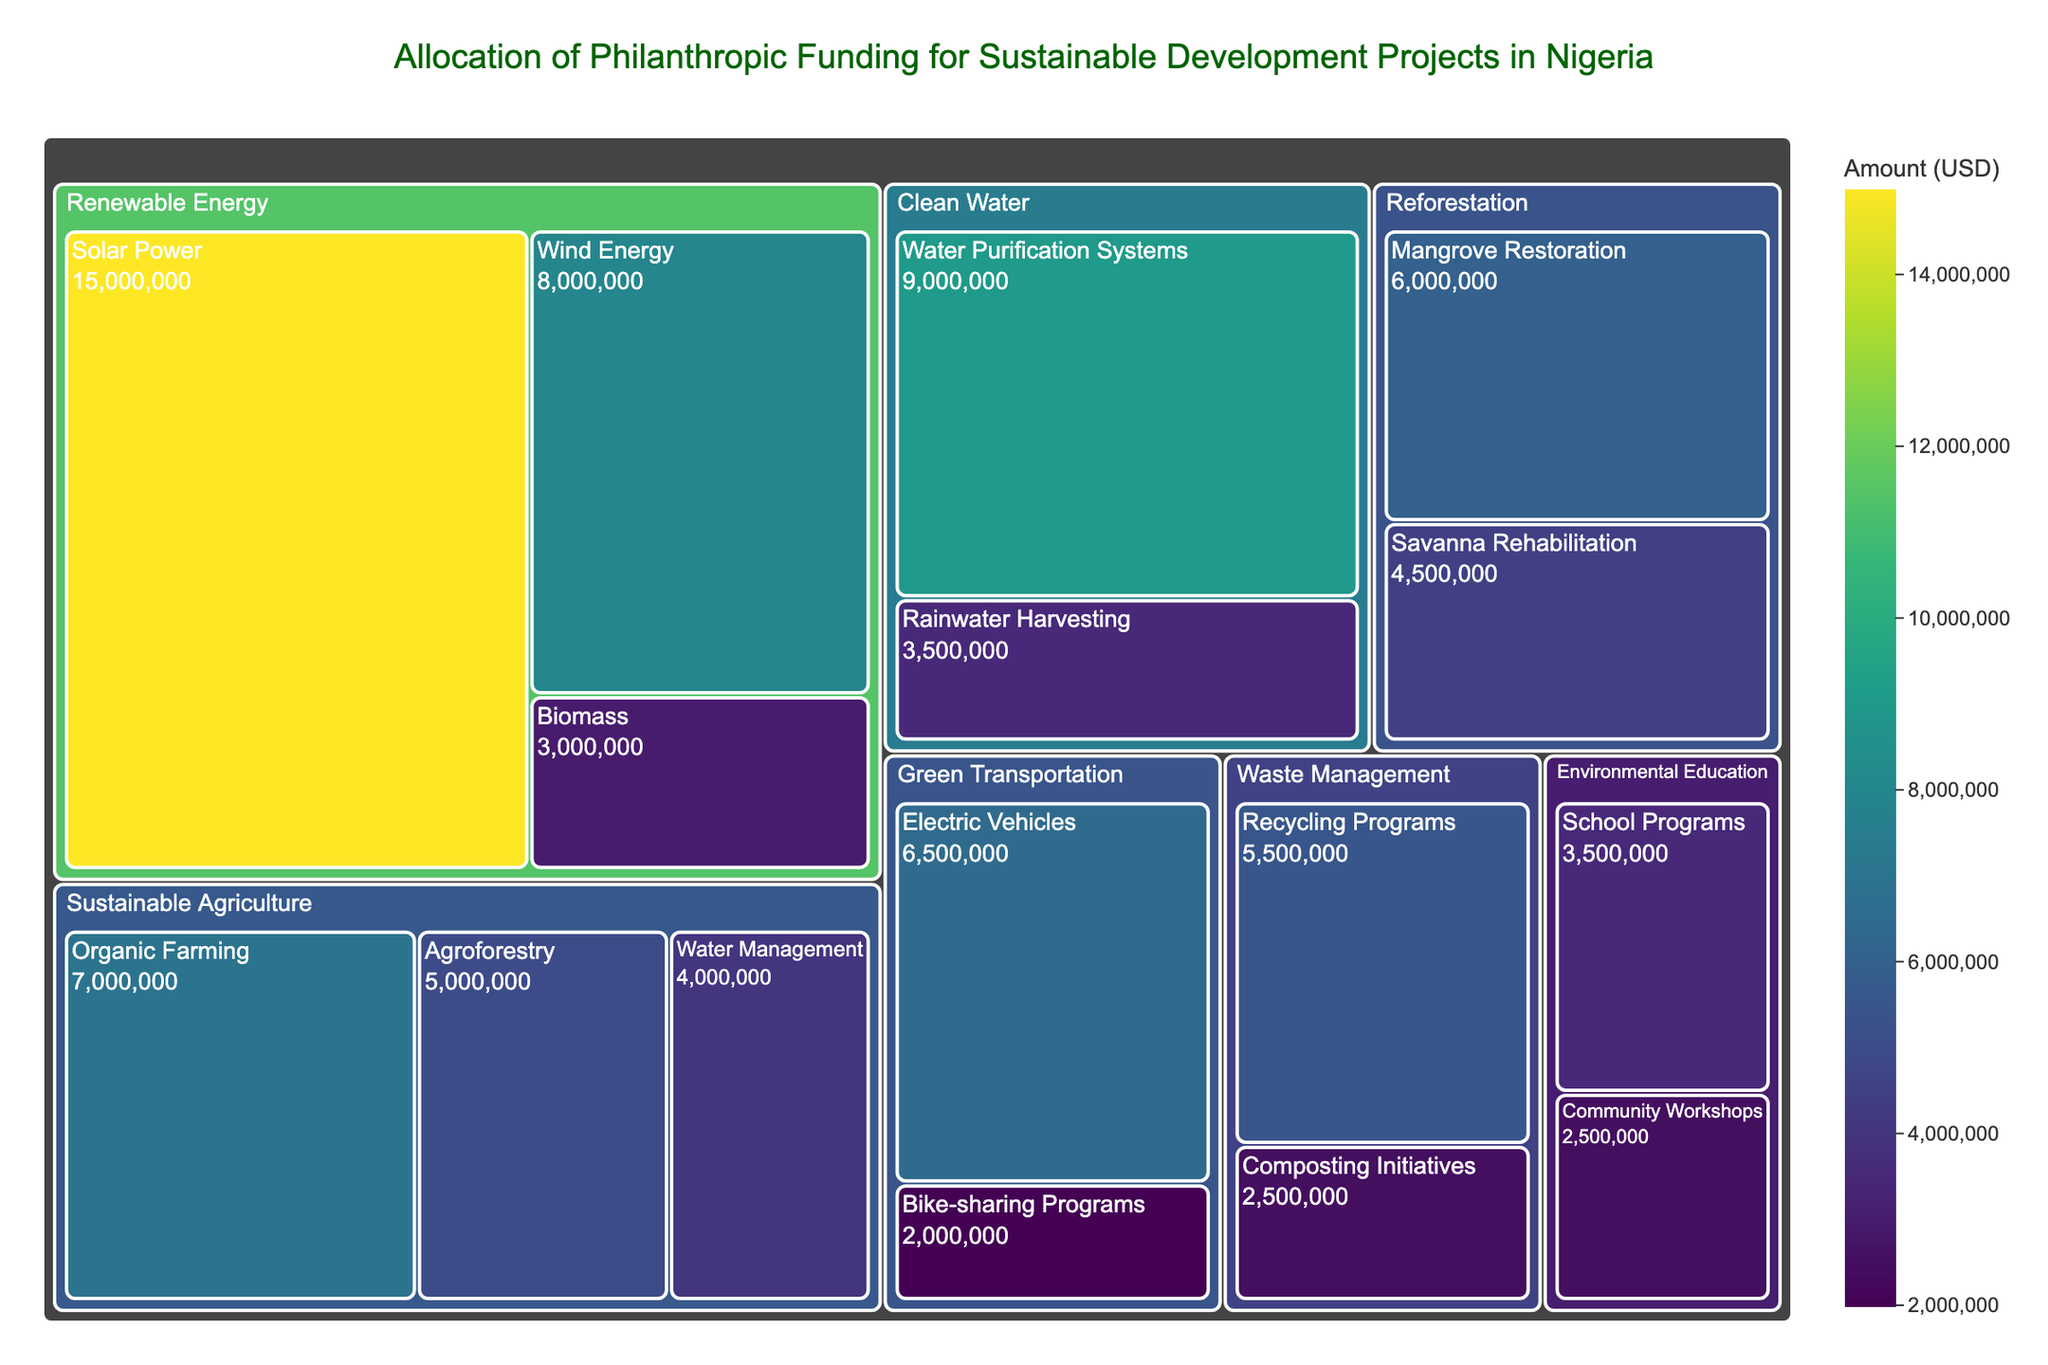What is the largest category of funding? The largest category can be identified by comparing the sizes of the blocks. The "Renewable Energy" category has the largest combined area, which indicates the highest funding amount.
Answer: Renewable Energy Which subcategory received the most funding? Within the "Renewable Energy" category, "Solar Power" is the subcategory with the largest block, indicating the highest funding.
Answer: Solar Power How much funding did Waste Management receive in total? Waste Management consists of "Recycling Programs" and "Composting Initiatives", with funding amounts of $5,500,000 and $2,500,000 respectively. Adding these gives $5,500,000 + $2,500,000 = $8,000,000.
Answer: $8,000,000 Which subcategory under Clean Water received more funding? Compare the sizes of the blocks under Clean Water. "Water Purification Systems" has a larger block than "Rainwater Harvesting."
Answer: Water Purification Systems What is the smallest category by funding amount? The smallest category can be found by identifying the smallest combined block area. "Green Transportation" has the smallest total block size.
Answer: Green Transportation What is the combined funding for Sustainable Agriculture and Reforestation? Add the total funding of Sustainable Agriculture ($7,000,000 + $5,000,000 + $4,000,000 = $16,000,000) and Reforestation ($6,000,000 + $4,500,000 = $10,500,000). The combined funding is $16,000,000 + $10,500,000 = $26,500,000.
Answer: $26,500,000 Which subcategory under Sustainable Agriculture has the least funding? Compare the sizes of the blocks under Sustainable Agriculture. "Water Management" has the smallest block.
Answer: Water Management Is the funding for Recycling Programs greater than for Water Purification Systems? Compare the amounts: Recycling Programs received $5,500,000 while Water Purification Systems received $9,000,000. $5,500,000 is less than $9,000,000.
Answer: No What is the percentage of total funding allocated to Environmental Education? Calculate the total funding: $15,000,000 + $8,000,000 + $3,000,000 + $7,000,000 + $5,000,000 + $4,000,000 + $6,000,000 + $4,500,000 + $9,000,000 + $3,500,000 + $5,500,000 + $2,500,000 + $6,500,000 + $2,000,000 + $3,500,000 + $2,500,000 = $93,500,000. Environmental Education received $3,500,000 + $2,500,000 = $6,000,000. The percentage is ($6,000,000 / $93,500,000) * 100 ≈ 6.4%.
Answer: 6.4% How much more funding did Electric Vehicles receive compared to Bike-sharing Programs? Electric Vehicles received $6,500,000 and Bike-sharing Programs received $2,000,000. The difference is $6,500,000 - $2,000,000 = $4,500,000.
Answer: $4,500,000 